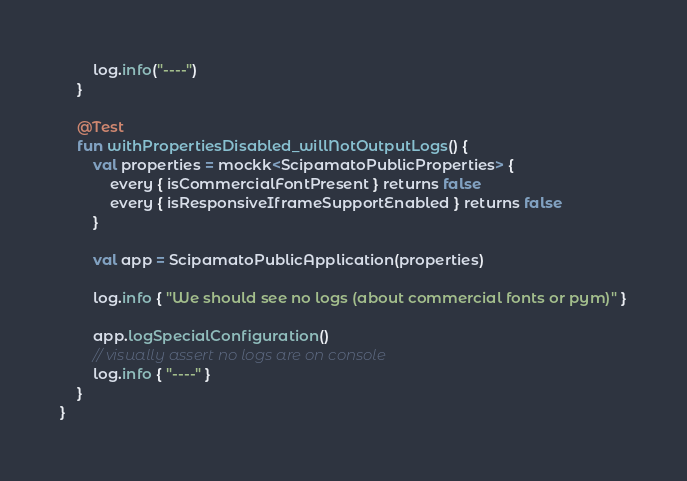<code> <loc_0><loc_0><loc_500><loc_500><_Kotlin_>        log.info("----")
    }

    @Test
    fun withPropertiesDisabled_willNotOutputLogs() {
        val properties = mockk<ScipamatoPublicProperties> {
            every { isCommercialFontPresent } returns false
            every { isResponsiveIframeSupportEnabled } returns false
        }

        val app = ScipamatoPublicApplication(properties)

        log.info { "We should see no logs (about commercial fonts or pym)" }

        app.logSpecialConfiguration()
        // visually assert no logs are on console
        log.info { "----" }
    }
}
</code> 